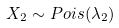Convert formula to latex. <formula><loc_0><loc_0><loc_500><loc_500>X _ { 2 } \sim P o i s ( \lambda _ { 2 } )</formula> 